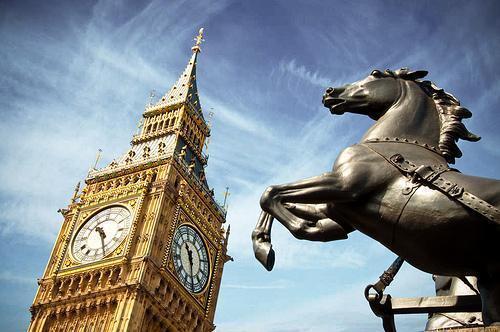How many statues are there?
Give a very brief answer. 1. 